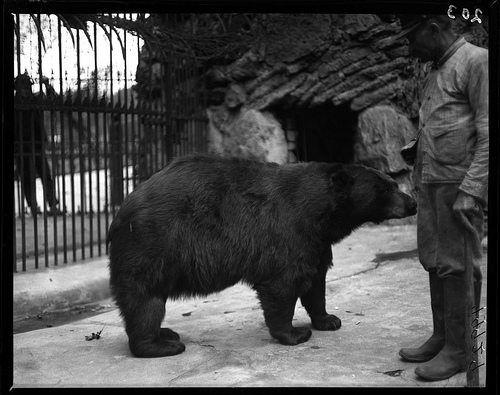Please transcribe the text in this image. 203 